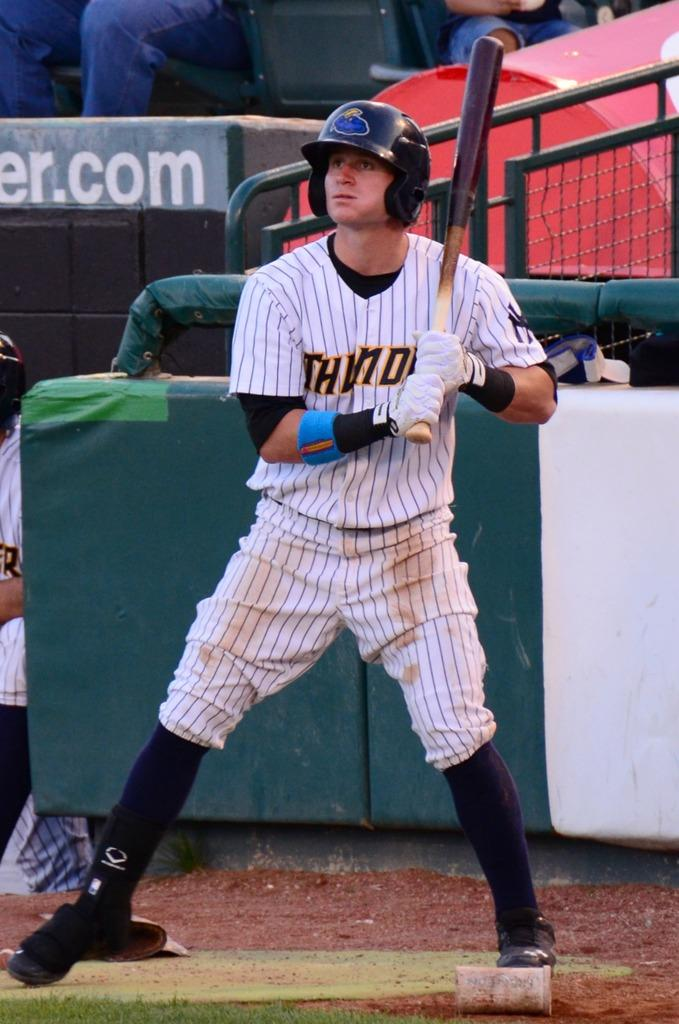<image>
Present a compact description of the photo's key features. Over the dugout there is a sign that ends with "er.com". 